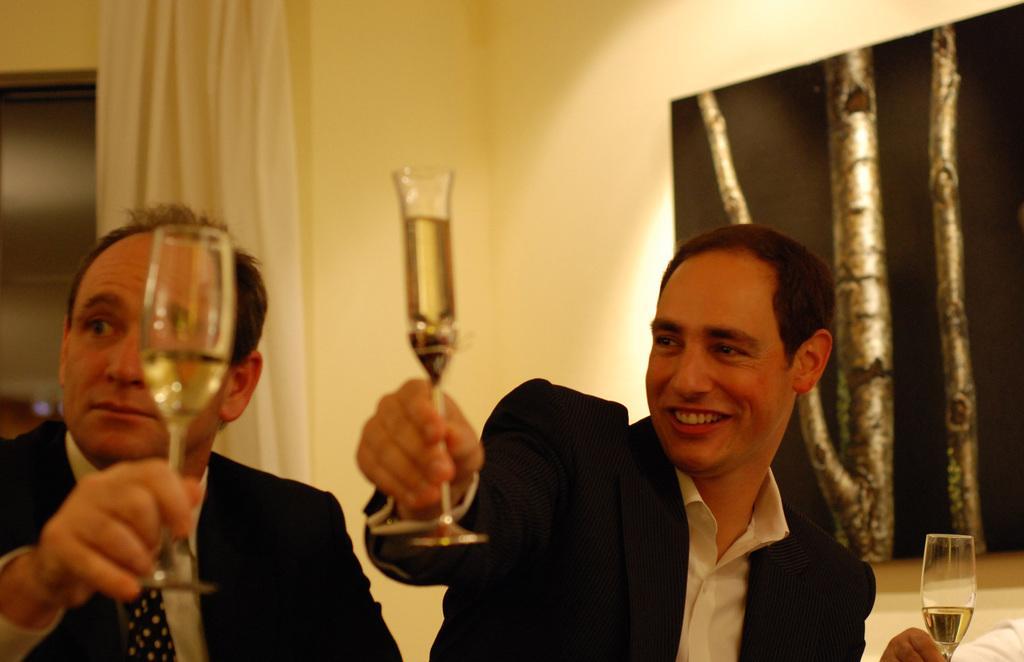Can you describe this image briefly? In this image we can see two persons are holding a glass with drink in it. In the background we can see a curtain, photo frame on wall. 